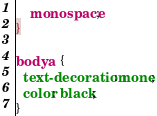<code> <loc_0><loc_0><loc_500><loc_500><_CSS_>    monospace;
}

body a {
  text-decoration: none;
  color: black;
}
</code> 